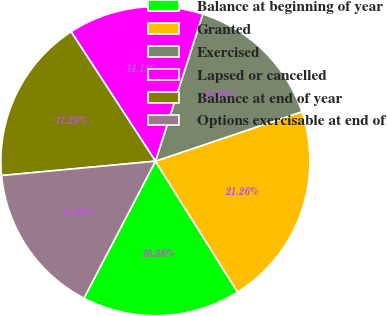<chart> <loc_0><loc_0><loc_500><loc_500><pie_chart><fcel>Balance at beginning of year<fcel>Granted<fcel>Exercised<fcel>Lapsed or cancelled<fcel>Balance at end of year<fcel>Options exercisable at end of<nl><fcel>16.58%<fcel>21.26%<fcel>14.86%<fcel>14.15%<fcel>17.29%<fcel>15.86%<nl></chart> 